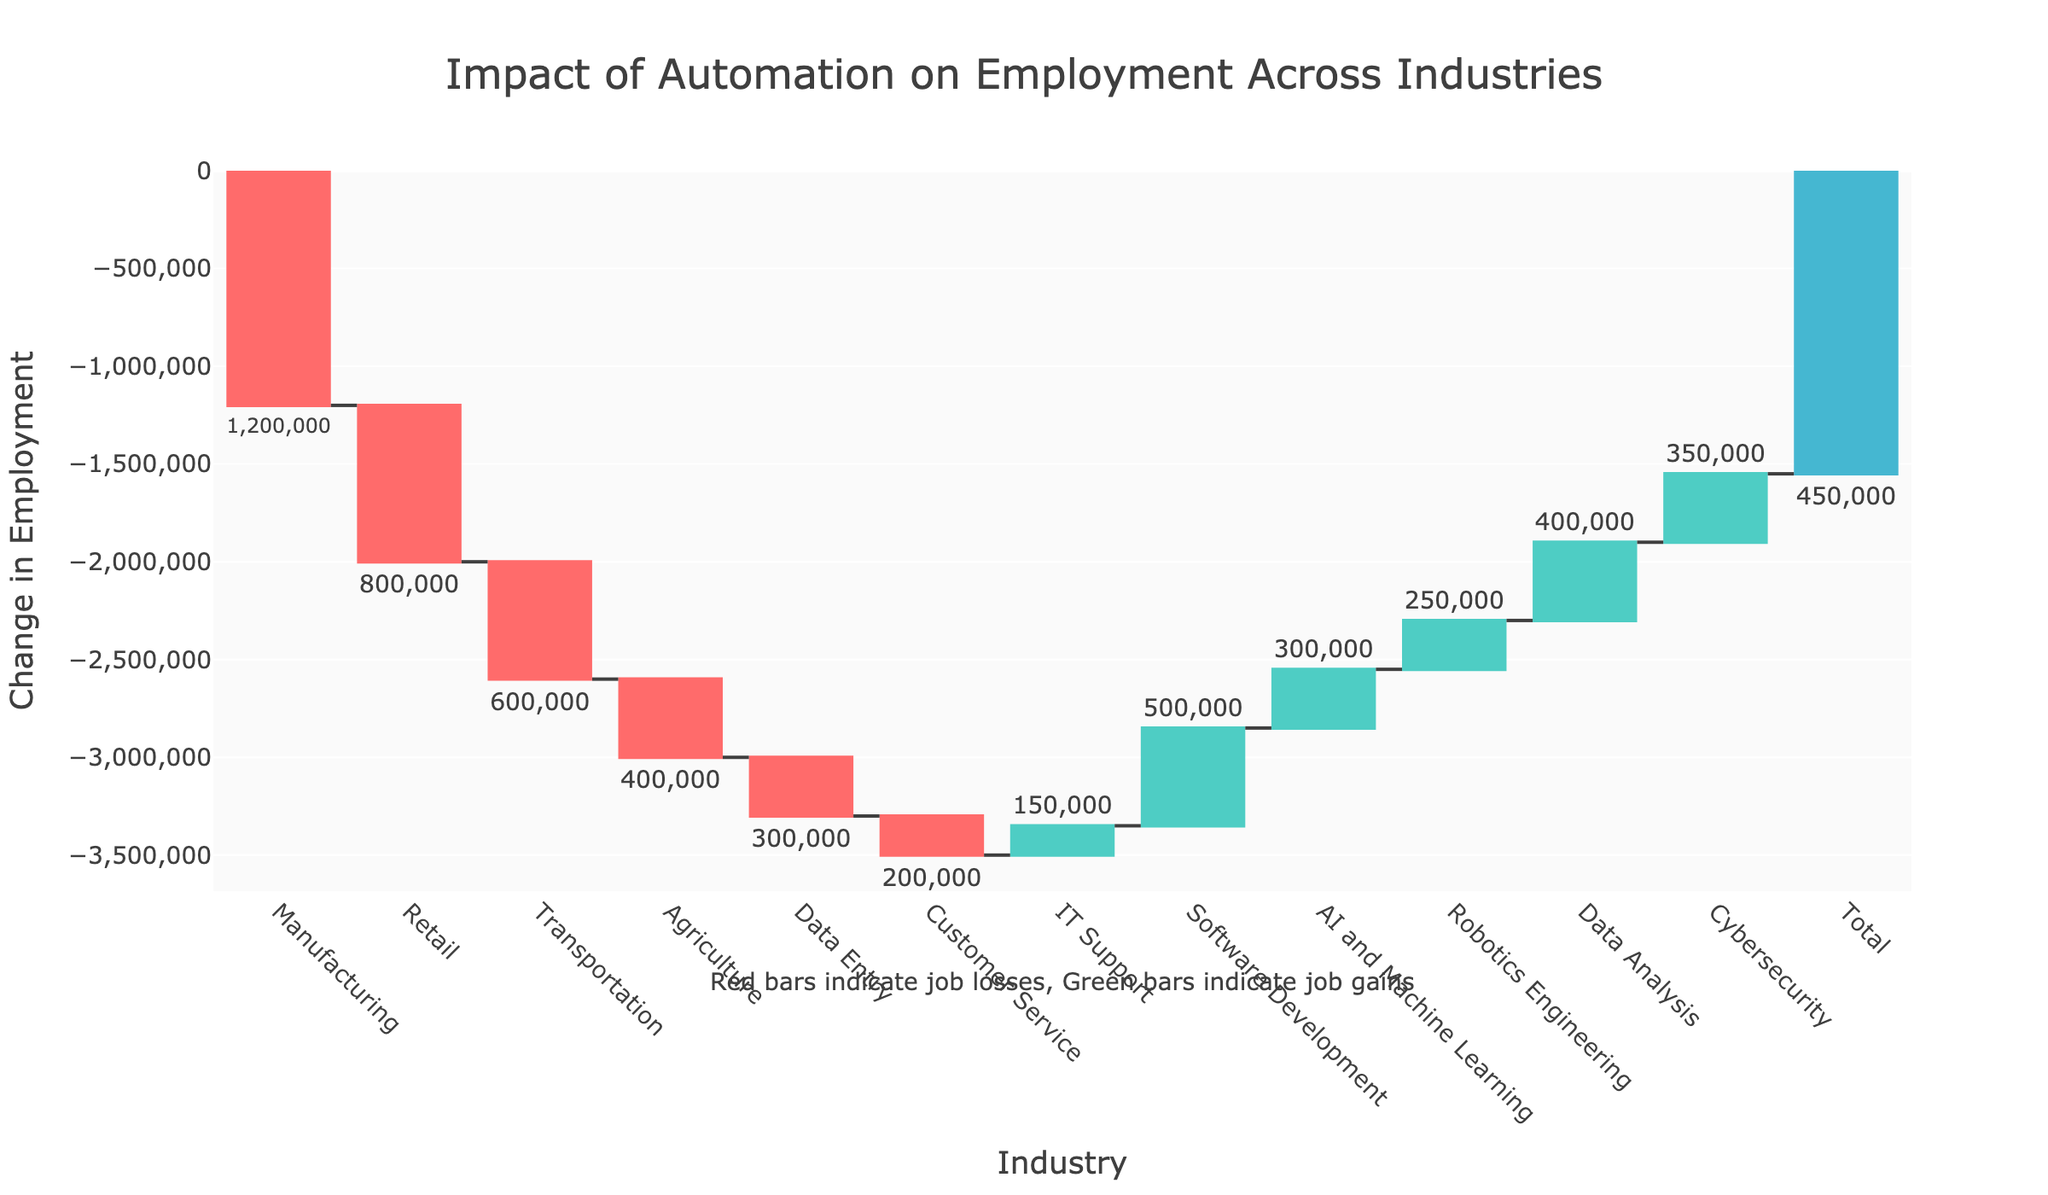How many industries experienced job losses due to automation? Count the industries with negative values in the Waterfall Chart. Manufacturing, Retail, Transportation, Agriculture, Data Entry, and Customer Service all have job losses.
Answer: 6 Which industry had the highest job gain? Look at the industry with the highest positive bar height. Software Development has the highest positive value.
Answer: Software Development What is the total net change in employment across all industries? Check the value shown in the total bar at the end of the Waterfall Chart. The total is explicitly shown as 450,000.
Answer: 450,000 How much bigger is the job loss in Manufacturing compared to Agriculture? Subtract the job change in Agriculture from Manufacturing: -1,200,000 - (-400,000) = -800,000.
Answer: 800,000 By how much did Software Development increase employment compared to IT Support? Subtract the job change in IT Support from Software Development: 500,000 - 150,000 = 350,000.
Answer: 350,000 What percentage of the total job gains are attributed to Data Analysis and Cybersecurity combined? Add the job changes for Data Analysis and Cybersecurity: 400,000 + 350,000 = 750,000. Then, divide this by the total job gains (ignoring losses): 750,000 / (150,000 + 500,000 + 300,000 + 250,000 + 400,000 + 350,000) = 750,000 / 1,950,000 ≈ 0.3846. Multiply by 100 to get the percentage: 0.3846 * 100 ≈ 38.46%.
Answer: 38.46% What is the color code used to represent job losses in the chart? The color for job losses (negative values) in the Waterfall Chart is red.
Answer: Red Which industry had a job change closest to -600,000? Compare the job changes, and Transportation is closest with a change of -600,000.
Answer: Transportation 